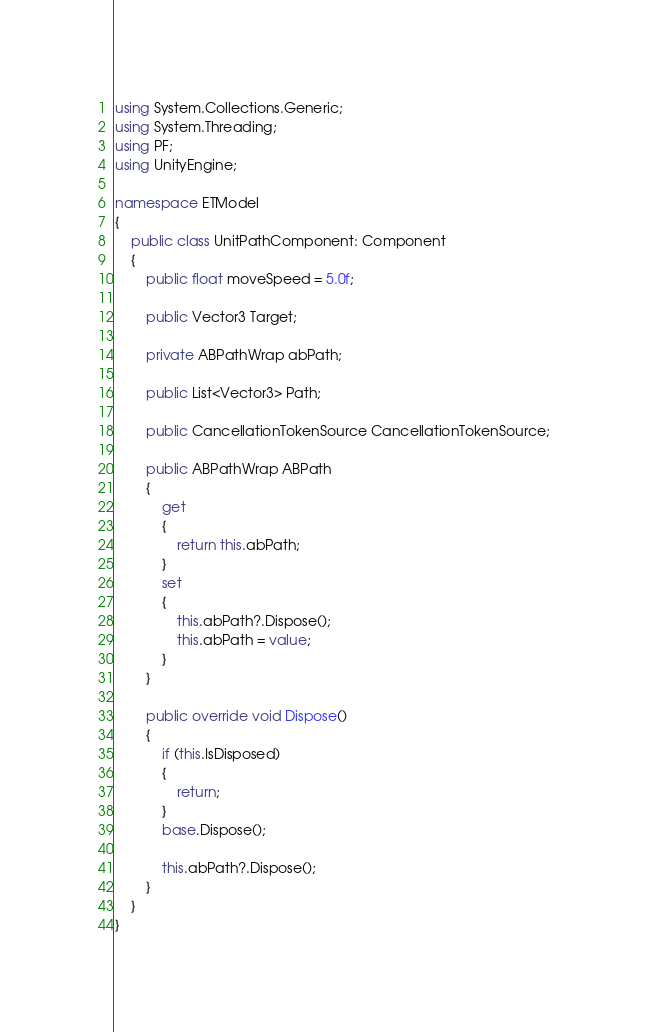Convert code to text. <code><loc_0><loc_0><loc_500><loc_500><_C#_>using System.Collections.Generic;
using System.Threading;
using PF;
using UnityEngine;

namespace ETModel
{
    public class UnitPathComponent: Component
    {
        public float moveSpeed = 5.0f;

        public Vector3 Target;

        private ABPathWrap abPath;
        
        public List<Vector3> Path;

        public CancellationTokenSource CancellationTokenSource;

        public ABPathWrap ABPath
        {
            get
            {
                return this.abPath;
            }
            set
            {
                this.abPath?.Dispose();
                this.abPath = value;
            }
        }

        public override void Dispose()
        {
            if (this.IsDisposed)
            {
                return;
            }
            base.Dispose();
            
            this.abPath?.Dispose();
        }
    }
}</code> 